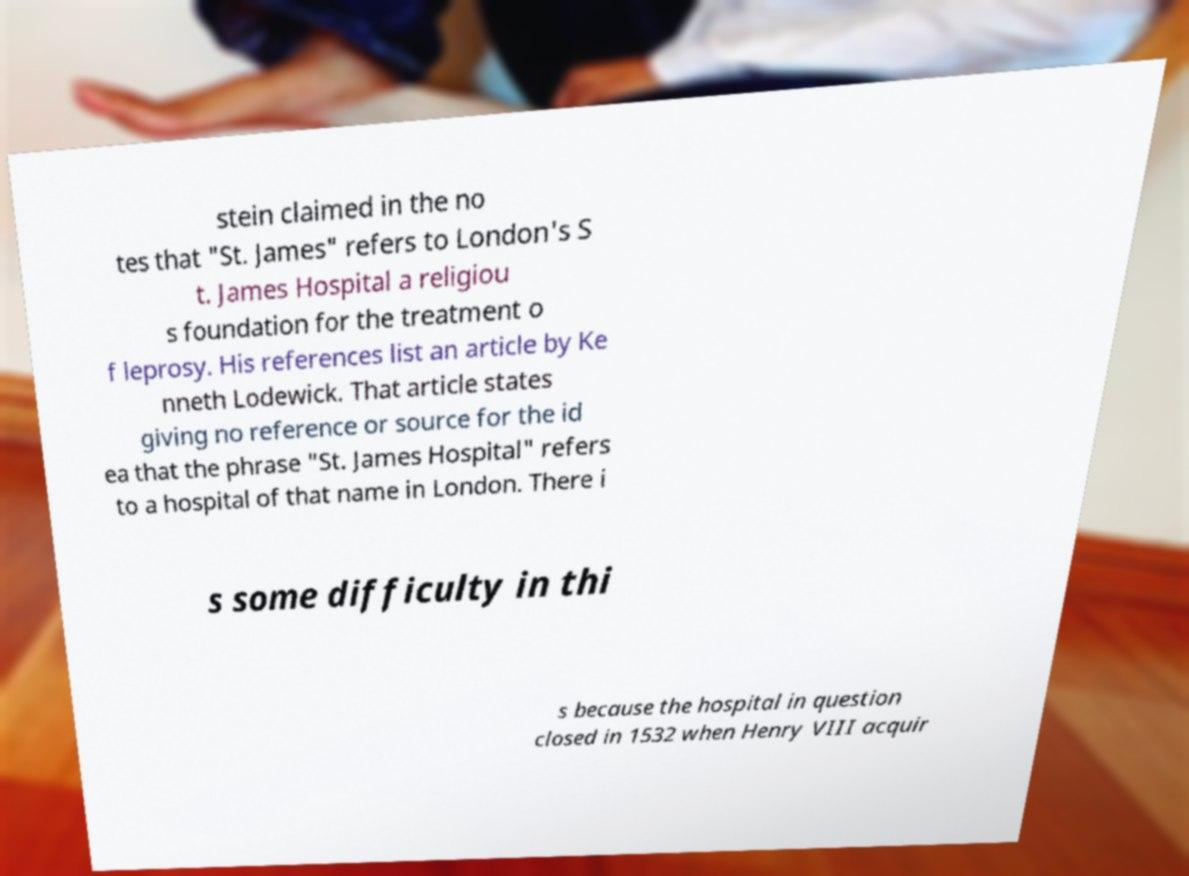What messages or text are displayed in this image? I need them in a readable, typed format. stein claimed in the no tes that "St. James" refers to London's S t. James Hospital a religiou s foundation for the treatment o f leprosy. His references list an article by Ke nneth Lodewick. That article states giving no reference or source for the id ea that the phrase "St. James Hospital" refers to a hospital of that name in London. There i s some difficulty in thi s because the hospital in question closed in 1532 when Henry VIII acquir 